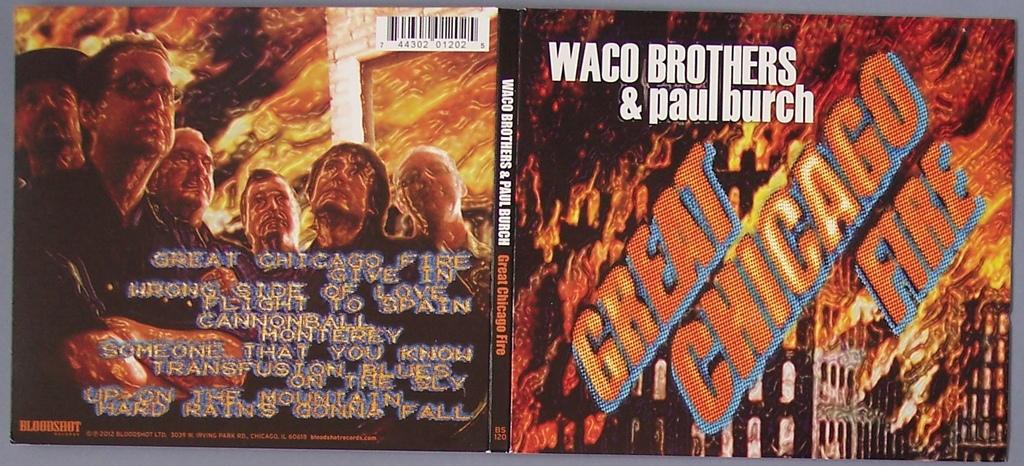What city was the fire in?
Offer a terse response. Chicago. Who sang this cd?
Your response must be concise. Waco brothers & paul burch. 